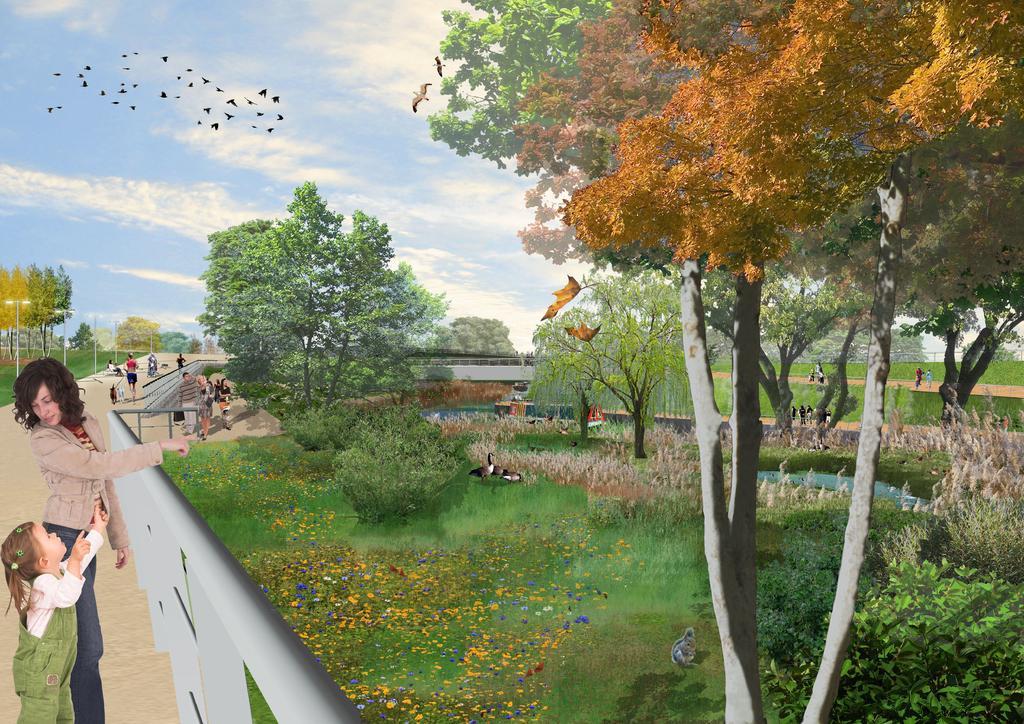Can you describe this image briefly? In this image I can see there are few people on the left side and there are few trees, birds in the sky and the sky is clear. 